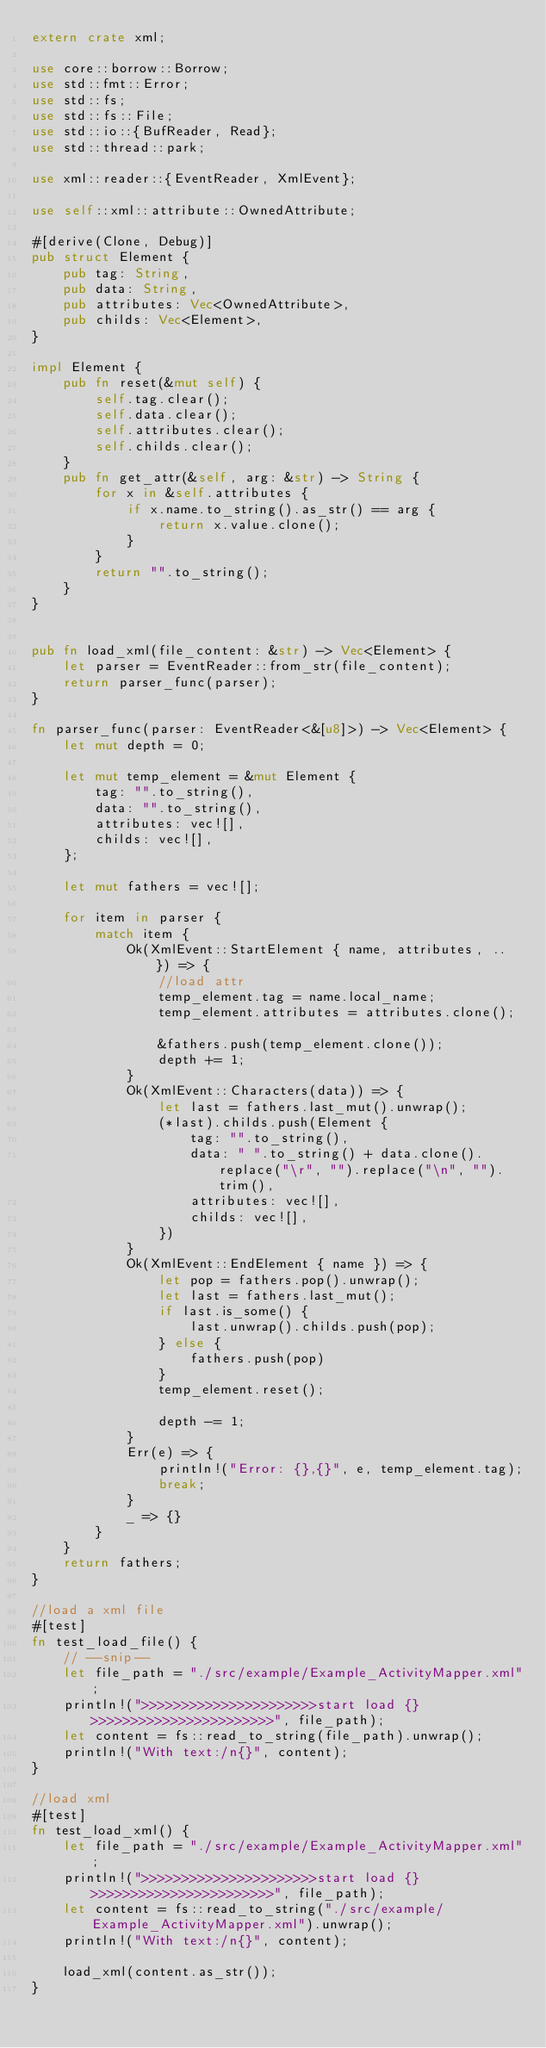Convert code to text. <code><loc_0><loc_0><loc_500><loc_500><_Rust_>extern crate xml;

use core::borrow::Borrow;
use std::fmt::Error;
use std::fs;
use std::fs::File;
use std::io::{BufReader, Read};
use std::thread::park;

use xml::reader::{EventReader, XmlEvent};

use self::xml::attribute::OwnedAttribute;

#[derive(Clone, Debug)]
pub struct Element {
    pub tag: String,
    pub data: String,
    pub attributes: Vec<OwnedAttribute>,
    pub childs: Vec<Element>,
}

impl Element {
    pub fn reset(&mut self) {
        self.tag.clear();
        self.data.clear();
        self.attributes.clear();
        self.childs.clear();
    }
    pub fn get_attr(&self, arg: &str) -> String {
        for x in &self.attributes {
            if x.name.to_string().as_str() == arg {
                return x.value.clone();
            }
        }
        return "".to_string();
    }
}


pub fn load_xml(file_content: &str) -> Vec<Element> {
    let parser = EventReader::from_str(file_content);
    return parser_func(parser);
}

fn parser_func(parser: EventReader<&[u8]>) -> Vec<Element> {
    let mut depth = 0;

    let mut temp_element = &mut Element {
        tag: "".to_string(),
        data: "".to_string(),
        attributes: vec![],
        childs: vec![],
    };

    let mut fathers = vec![];

    for item in parser {
        match item {
            Ok(XmlEvent::StartElement { name, attributes, .. }) => {
                //load attr
                temp_element.tag = name.local_name;
                temp_element.attributes = attributes.clone();

                &fathers.push(temp_element.clone());
                depth += 1;
            }
            Ok(XmlEvent::Characters(data)) => {
                let last = fathers.last_mut().unwrap();
                (*last).childs.push(Element {
                    tag: "".to_string(),
                    data: " ".to_string() + data.clone().replace("\r", "").replace("\n", "").trim(),
                    attributes: vec![],
                    childs: vec![],
                })
            }
            Ok(XmlEvent::EndElement { name }) => {
                let pop = fathers.pop().unwrap();
                let last = fathers.last_mut();
                if last.is_some() {
                    last.unwrap().childs.push(pop);
                } else {
                    fathers.push(pop)
                }
                temp_element.reset();

                depth -= 1;
            }
            Err(e) => {
                println!("Error: {},{}", e, temp_element.tag);
                break;
            }
            _ => {}
        }
    }
    return fathers;
}

//load a xml file
#[test]
fn test_load_file() {
    // --snip--
    let file_path = "./src/example/Example_ActivityMapper.xml";
    println!(">>>>>>>>>>>>>>>>>>>>>>start load {} >>>>>>>>>>>>>>>>>>>>>>>", file_path);
    let content = fs::read_to_string(file_path).unwrap();
    println!("With text:/n{}", content);
}

//load xml
#[test]
fn test_load_xml() {
    let file_path = "./src/example/Example_ActivityMapper.xml";
    println!(">>>>>>>>>>>>>>>>>>>>>>start load {} >>>>>>>>>>>>>>>>>>>>>>>", file_path);
    let content = fs::read_to_string("./src/example/Example_ActivityMapper.xml").unwrap();
    println!("With text:/n{}", content);

    load_xml(content.as_str());
}</code> 